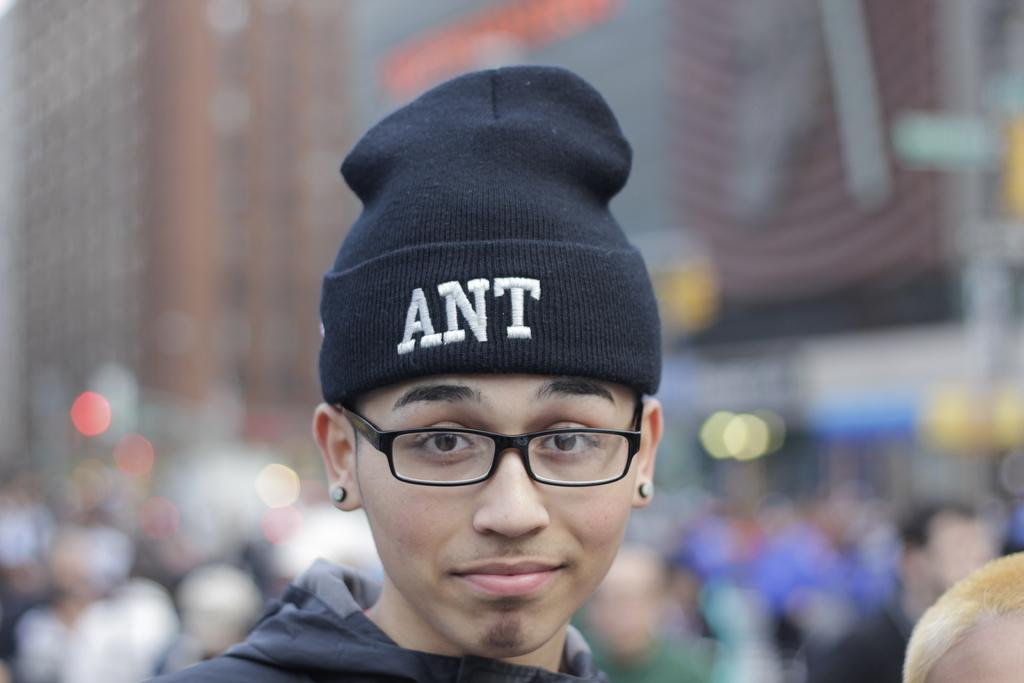Who or what is the main subject of the image? There is a person in the image. What is the person wearing on their head? The person is wearing a cap. What type of eyewear is the person wearing? The person is wearing spectacles. Can you describe the background? The background of the image is blurred. What day of the week is depicted in the image? There is no reference to a specific day of the week in the image. 